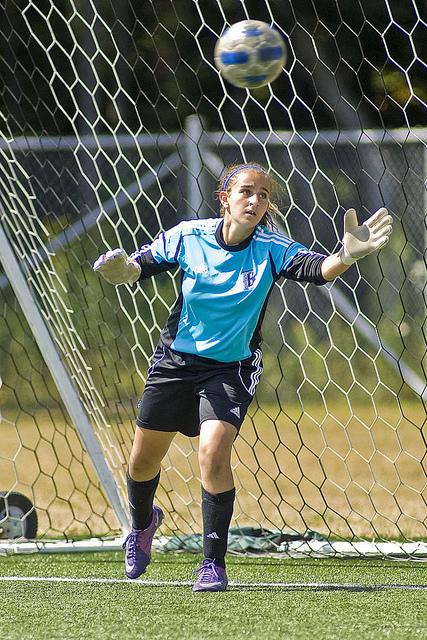Is this a professional player?
Keep it brief. No. Is the girl blocking the ball or kicking it?
Short answer required. Blocking. What position is this footballer playing?
Keep it brief. Goalie. Why is she wearing gloves?
Give a very brief answer. Protection. 